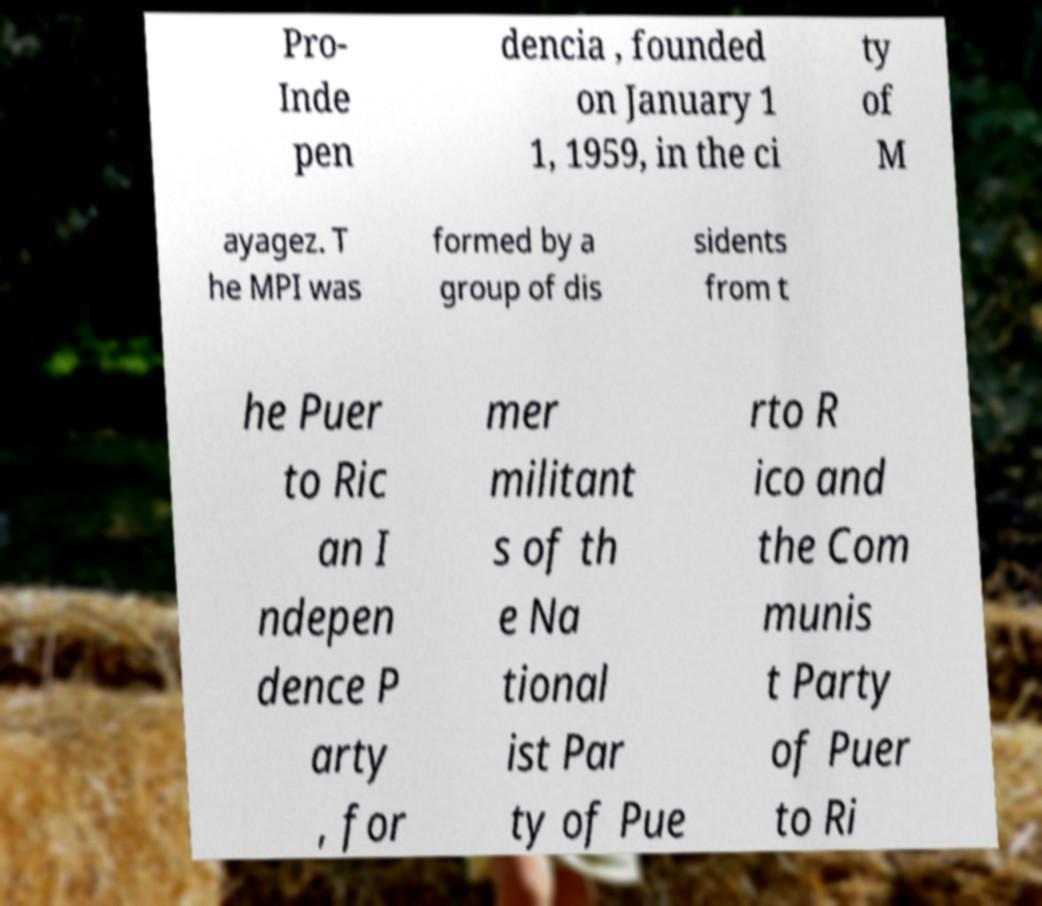Please identify and transcribe the text found in this image. Pro- Inde pen dencia , founded on January 1 1, 1959, in the ci ty of M ayagez. T he MPI was formed by a group of dis sidents from t he Puer to Ric an I ndepen dence P arty , for mer militant s of th e Na tional ist Par ty of Pue rto R ico and the Com munis t Party of Puer to Ri 